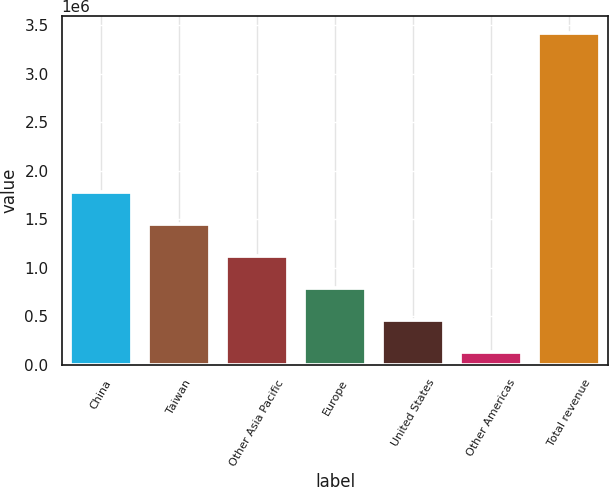Convert chart. <chart><loc_0><loc_0><loc_500><loc_500><bar_chart><fcel>China<fcel>Taiwan<fcel>Other Asia Pacific<fcel>Europe<fcel>United States<fcel>Other Americas<fcel>Total revenue<nl><fcel>1.77788e+06<fcel>1.44849e+06<fcel>1.11909e+06<fcel>789697<fcel>460301<fcel>130906<fcel>3.42486e+06<nl></chart> 